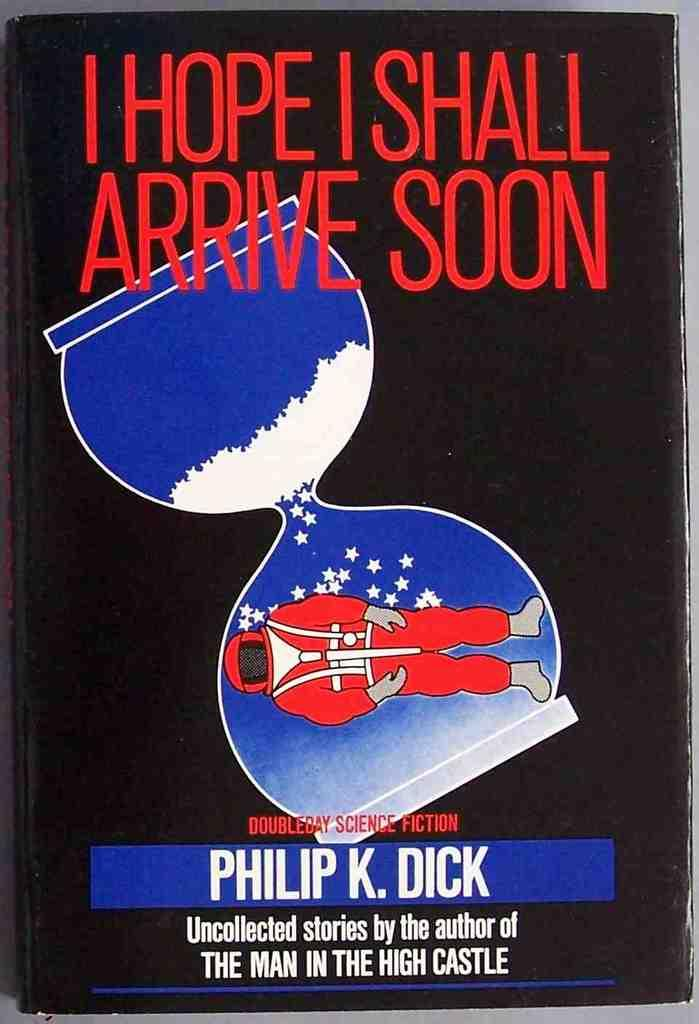What is featured on the poster in the image? There is a poster in the image, and it features a sand clock and a person. What is the purpose of the sand clock on the poster? The sand clock on the poster is likely used to represent the passage of time or a countdown. What else can be seen on the poster besides the sand clock and person? There is text on the poster. What type of paint is being used to create the sand clock on the poster? There is no information about the type of paint used on the poster, as the focus is on the sand clock and person depicted. 